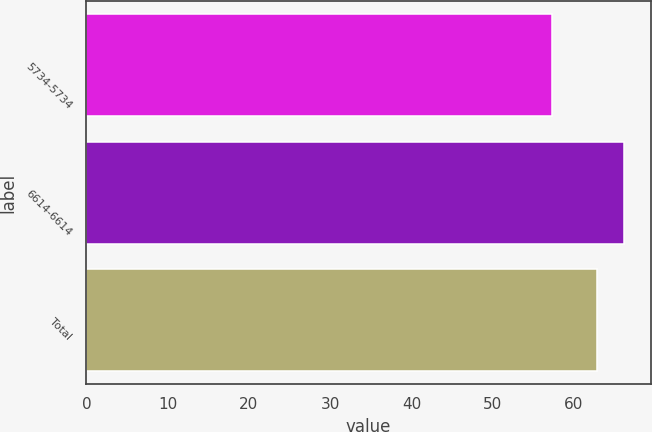Convert chart. <chart><loc_0><loc_0><loc_500><loc_500><bar_chart><fcel>5734-5734<fcel>6614-6614<fcel>Total<nl><fcel>57.34<fcel>66.14<fcel>62.86<nl></chart> 